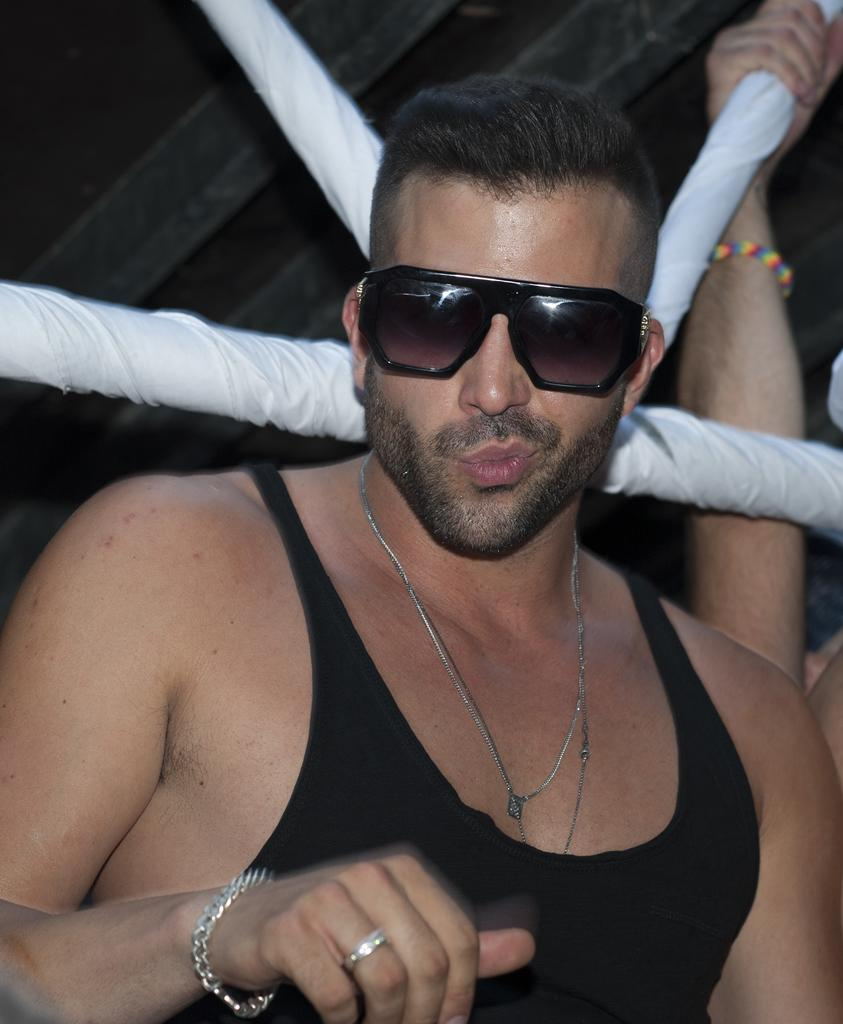Who or what is the main subject in the center of the image? There is a person in the center of the image. What accessory is the person wearing in the image? The person is wearing sunglasses. Can you describe any other visible body parts of the person in the image? There is a person's hand visible in the background of the image. How many frogs are visible in the image? There are no frogs present in the image. What type of hope can be seen in the person's expression in the image? The image does not convey any specific emotions or expressions, so it is not possible to determine the person's hope from the image. 